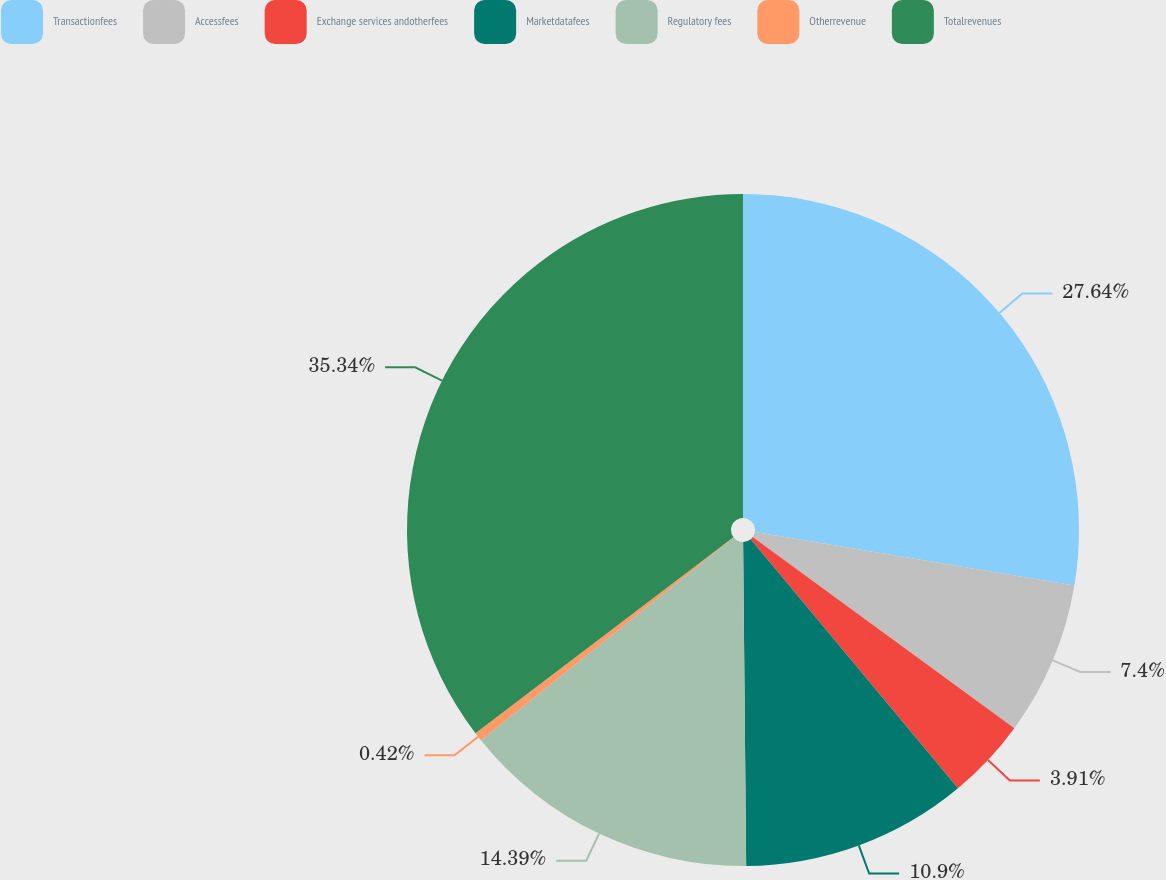Convert chart. <chart><loc_0><loc_0><loc_500><loc_500><pie_chart><fcel>Transactionfees<fcel>Accessfees<fcel>Exchange services andotherfees<fcel>Marketdatafees<fcel>Regulatory fees<fcel>Otherrevenue<fcel>Totalrevenues<nl><fcel>27.64%<fcel>7.4%<fcel>3.91%<fcel>10.9%<fcel>14.39%<fcel>0.42%<fcel>35.34%<nl></chart> 